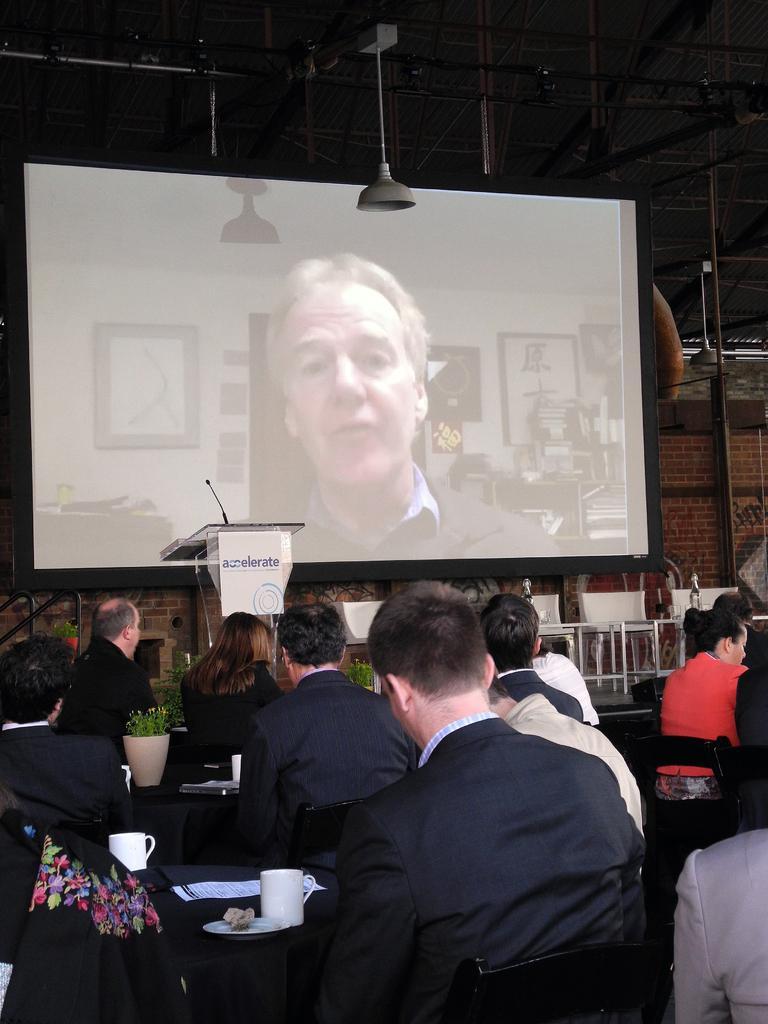Could you give a brief overview of what you see in this image? In this image there are so many people sitting on chairs, in front of them there is a mic table mic table, chairs and projector screen on the stage. 